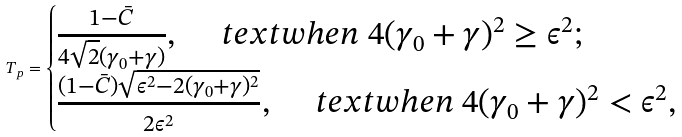Convert formula to latex. <formula><loc_0><loc_0><loc_500><loc_500>T _ { p } = \begin{cases} \frac { 1 - \bar { C } } { 4 \sqrt { 2 } ( \gamma _ { 0 } + \gamma ) } , \ \quad t e x t { w h e n } \ 4 ( \gamma _ { 0 } + \gamma ) ^ { 2 } \geq \epsilon ^ { 2 } ; \\ \frac { ( 1 - \bar { C } ) \sqrt { \epsilon ^ { 2 } - 2 ( \gamma _ { 0 } + \gamma ) ^ { 2 } } } { 2 \epsilon ^ { 2 } } , \ \quad t e x t { w h e n } \ 4 ( \gamma _ { 0 } + \gamma ) ^ { 2 } < \epsilon ^ { 2 } , \end{cases}</formula> 